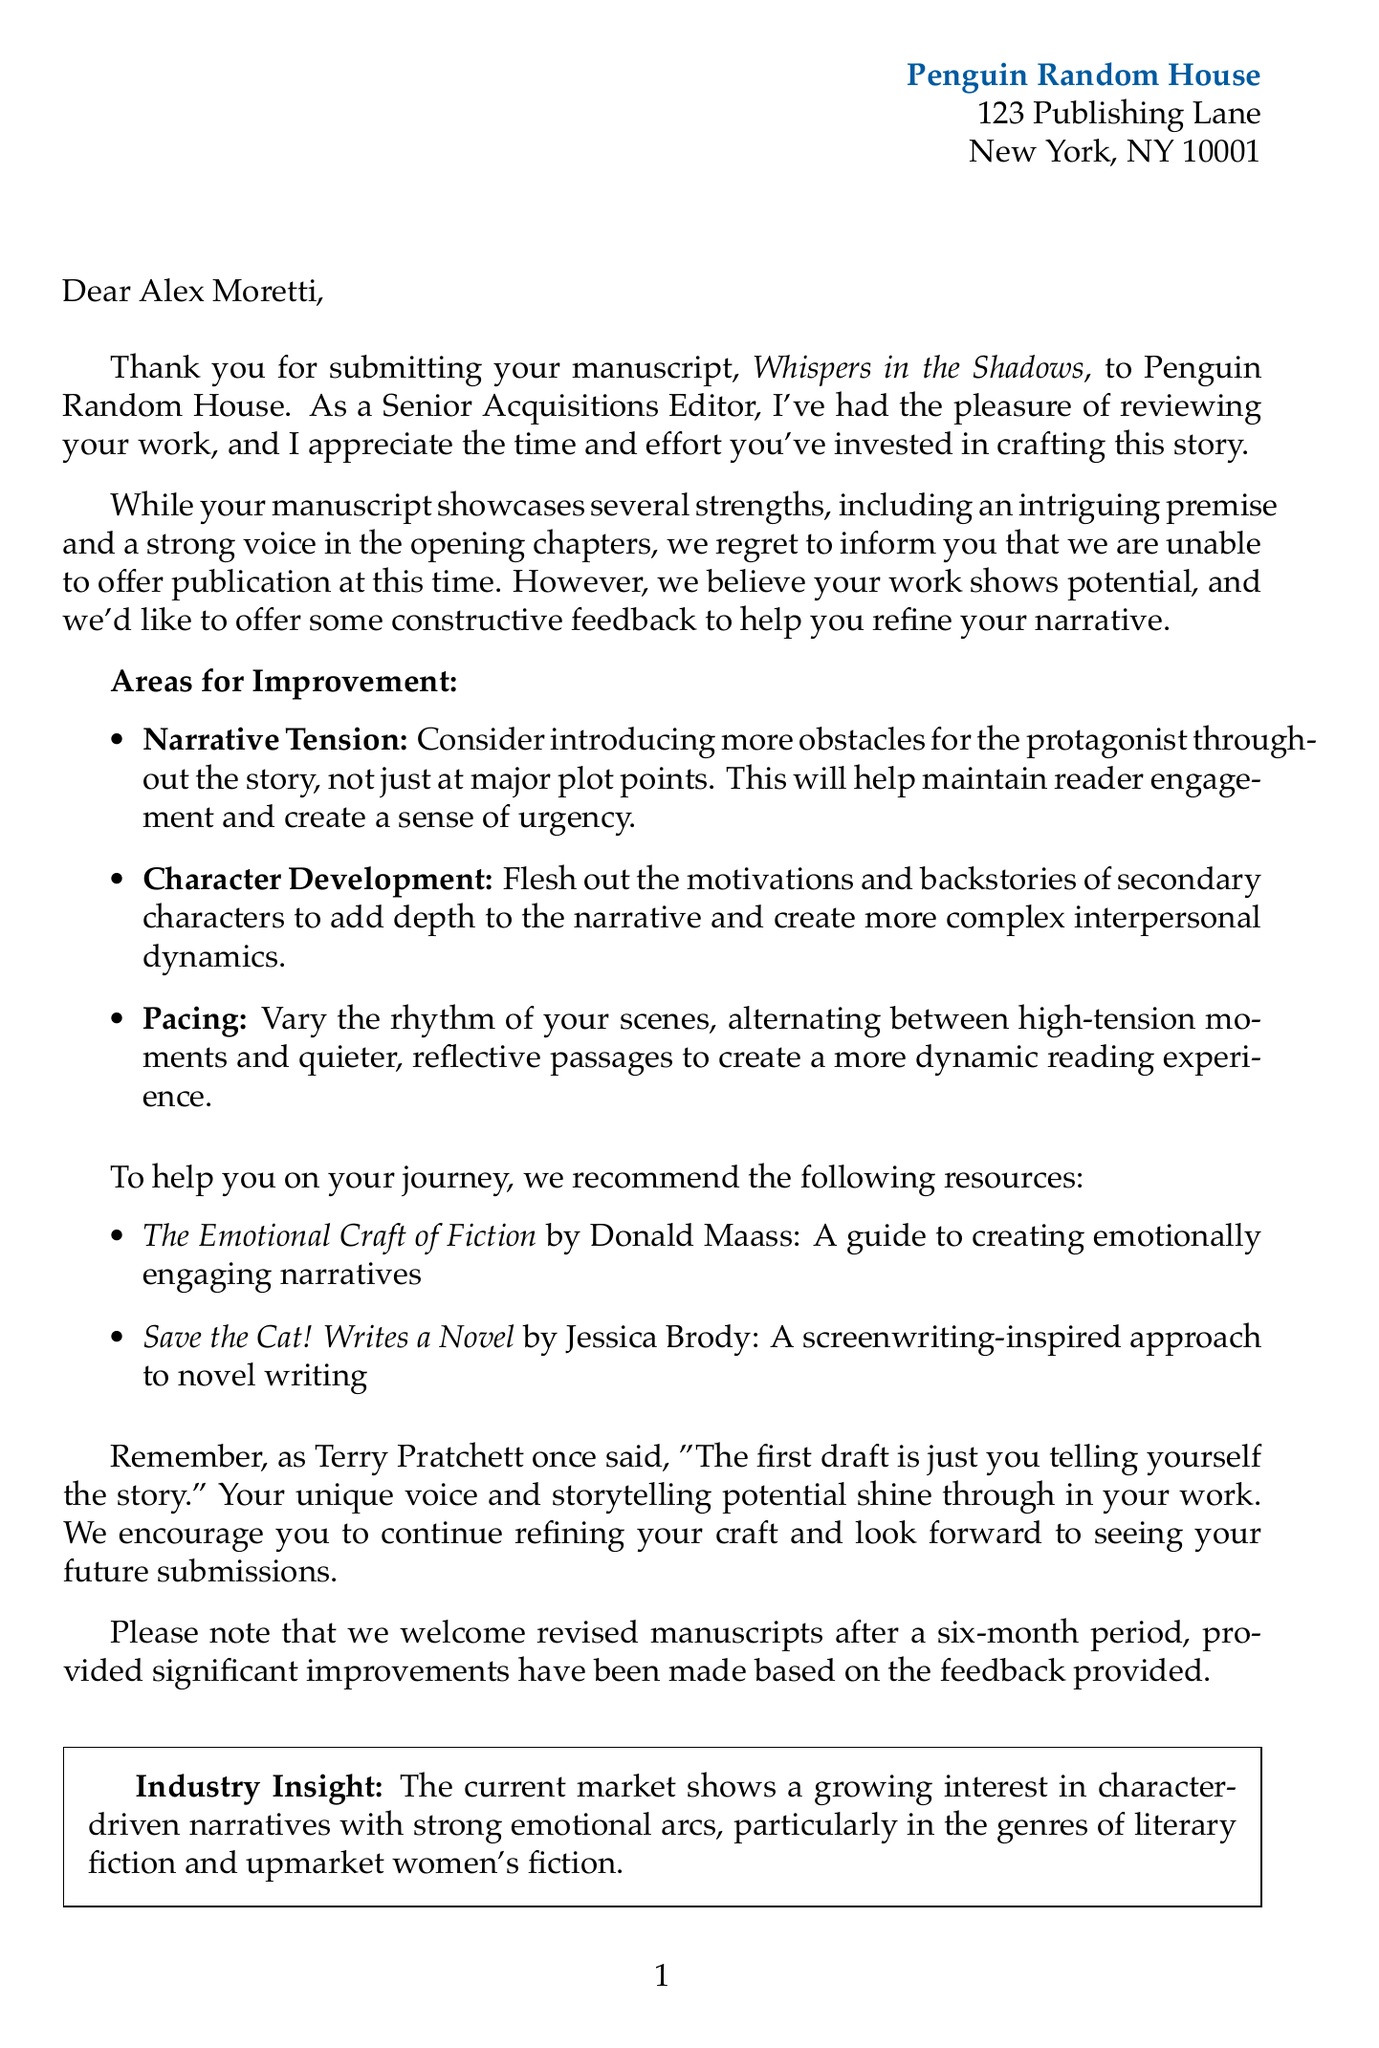What is the title of the manuscript? The title of the manuscript is stated in the letter as "Whispers in the Shadows."
Answer: Whispers in the Shadows Who is the Senior Acquisitions Editor? The document specifies the editor's name and position, which is "Sarah Thompson, Senior Acquisitions Editor."
Answer: Sarah Thompson What are two positive aspects of the manuscript? The letter highlights specific strengths of the manuscript, including "intriguing premise" and "strong voice in the opening chapters."
Answer: intriguing premise, strong voice in the opening chapters What should be introduced to improve narrative tension? The document suggests that "more obstacles for the protagonist" should be introduced throughout the story.
Answer: more obstacles for the protagonist What is the recommended resubmission period? The letter indicates the timeline for resubmission, which is after a six-month period.
Answer: six-month period What genre shows a growing interest according to the industry insight? The document mentions that there's a growing interest in "character-driven narratives" particularly in literary fiction and upmarket women's fiction.
Answer: character-driven narratives What type of insight does the editor provide about the current market? The editor shares information that reflects "industry insight," which specifically relates to market trends.
Answer: industry insight What is the first draft described as, according to a quote in the letter? The document includes a quote from Terry Pratchett describing the first draft as "just you telling yourself the story."
Answer: just you telling yourself the story 